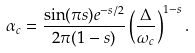Convert formula to latex. <formula><loc_0><loc_0><loc_500><loc_500>\alpha _ { c } = \frac { \sin ( \pi s ) e ^ { - s / 2 } } { 2 \pi ( 1 - s ) } \left ( \frac { \Delta } { \omega _ { c } } \right ) ^ { 1 - s } .</formula> 